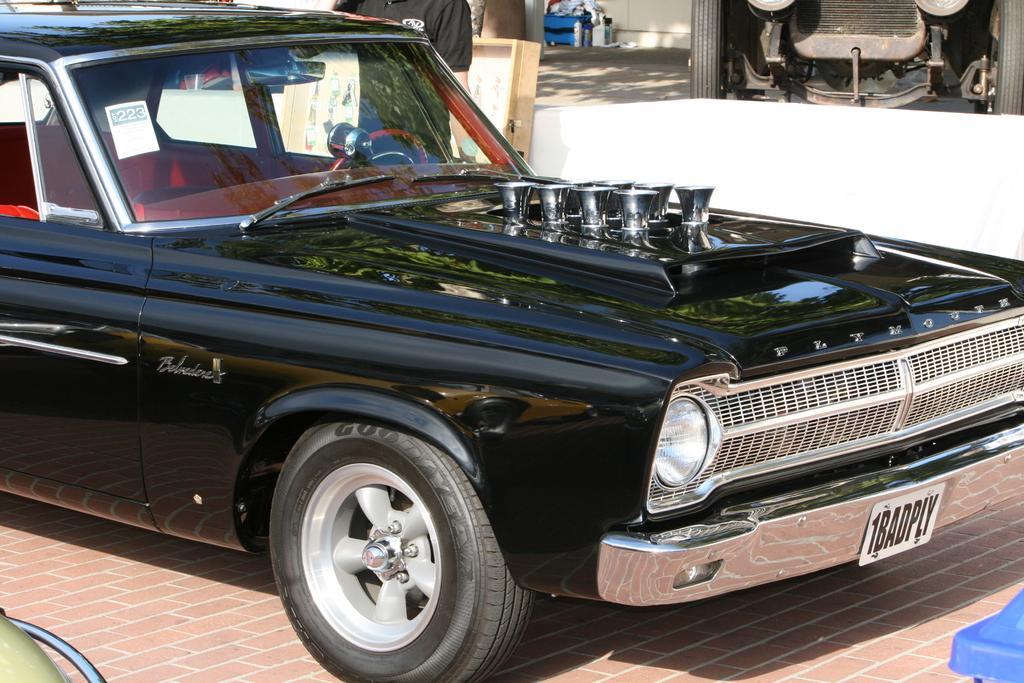In one or two sentences, can you explain what this image depicts? In the foreground of this image, there is a car. In the right and left bottom corner, there is a car and an object. In the background, there is man and a wooden object, trunk, wall, few objects and a vehicle. 